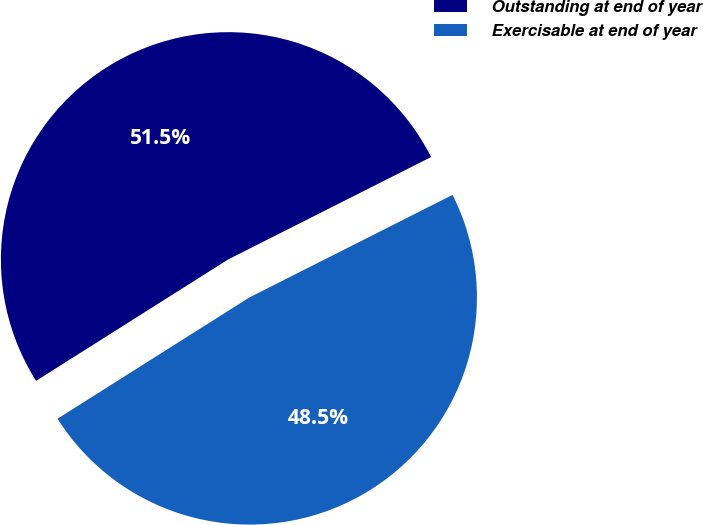Convert chart. <chart><loc_0><loc_0><loc_500><loc_500><pie_chart><fcel>Outstanding at end of year<fcel>Exercisable at end of year<nl><fcel>51.53%<fcel>48.47%<nl></chart> 